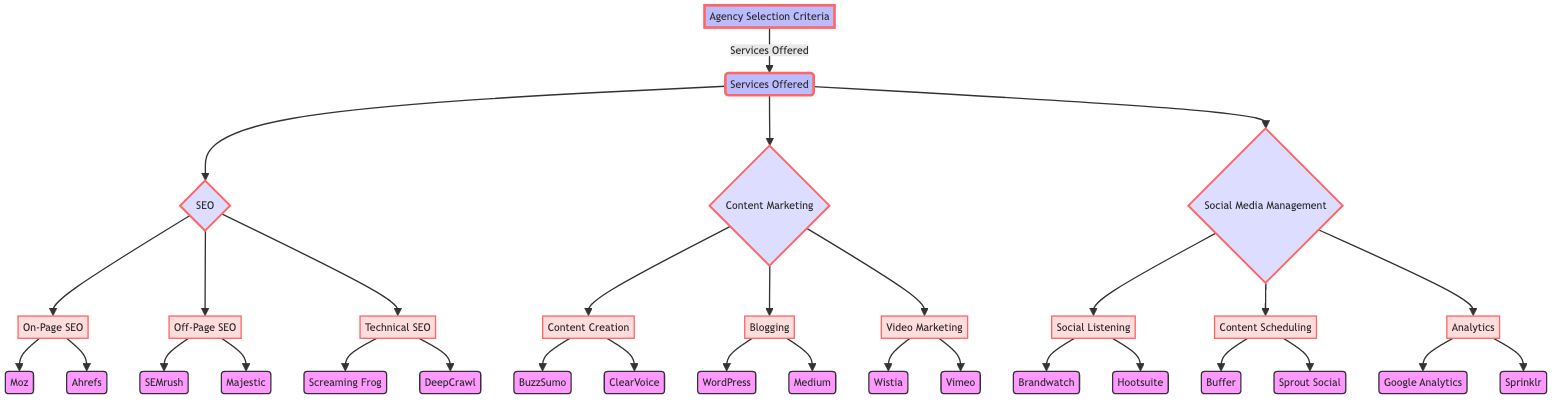What services are offered by the agency? The diagram indicates three main services offered by the agency, which are SEO, Content Marketing, and Social Media Management.
Answer: SEO, Content Marketing, Social Media Management How many nodes are associated with SEO? There are three sub-nodes under the SEO node: On-Page SEO, Off-Page SEO, and Technical SEO. Hence, the total is three nodes.
Answer: 3 Which tool is listed under On-Page SEO? The diagram shows that two tools are provided under On-Page SEO, and one of them is Moz.
Answer: Moz What is the total number of subcategories under Content Marketing? The Content Marketing section contains three subcategories: Content Creation, Blogging, and Video Marketing, totaling three subcategories.
Answer: 3 Which tools can be used for Social Listening? According to the diagram, Brandwatch and Hootsuite are the tools provided for Social Listening.
Answer: Brandwatch, Hootsuite Which service has the most tools listed? In the diagram, SEO lists a total of six tools across its subcategories (two for On-Page SEO, two for Off-Page SEO, and two for Technical SEO), making it the service with the most tools.
Answer: SEO If we choose Content Creation, what tools can we use? The diagram specifies that the tools available under the Content Creation subcategory are BuzzSumo and ClearVoice.
Answer: BuzzSumo, ClearVoice What is the relationship between Technical SEO and Screaming Frog? Screaming Frog is a tool that falls under the subcategory of Technical SEO, indicating that Screaming Frog is specifically referenced as a resource for that service area.
Answer: Tool under Technical SEO How many edges are there leading to Analytics? The diagram shows a path that leads from the Social Media Management node to the Analytics node, indicating a single edge leading to Analytics.
Answer: 1 